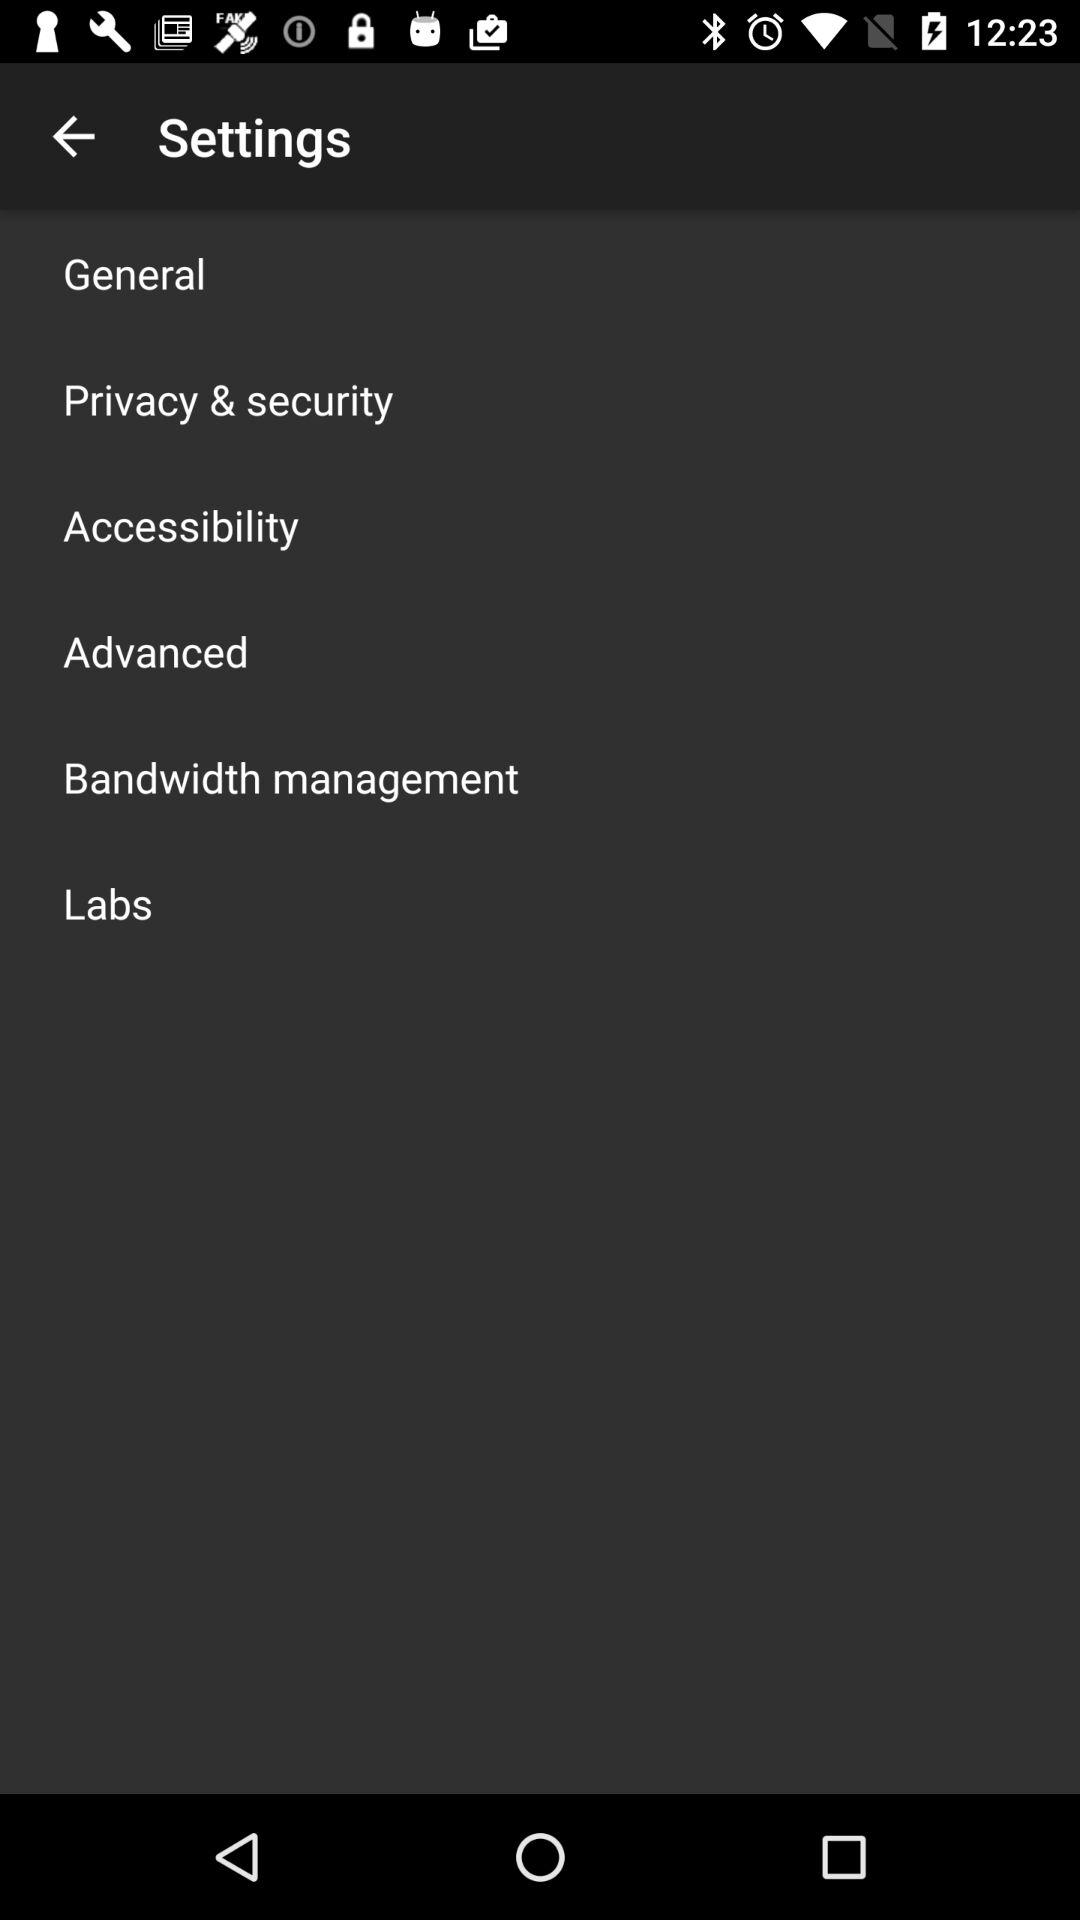How many items are in the settings menu?
Answer the question using a single word or phrase. 6 